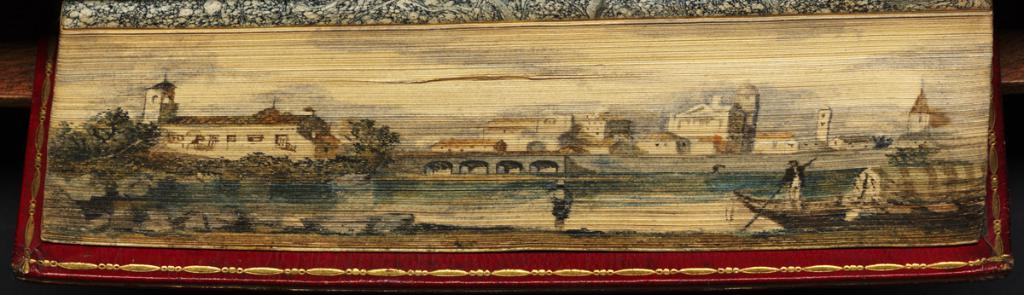What is the main subject in the foreground of the picture? There is a frame with a scenery in the foreground of the picture. What can be seen in the scenery? The scenery includes a man on a boat on the water, a bridge, trees, buildings, and the sky. Can you describe the water element in the scenery? The water element in the scenery is where the man is on a boat. What type of structures are visible in the scenery? Buildings are visible in the scenery. How many bananas are hanging from the bridge in the image? There are no bananas present in the image, and therefore no such activity can be observed. What letter does the man on the boat spell out with his arms? There is no indication in the image that the man on the boat is spelling out a letter with his arms. 